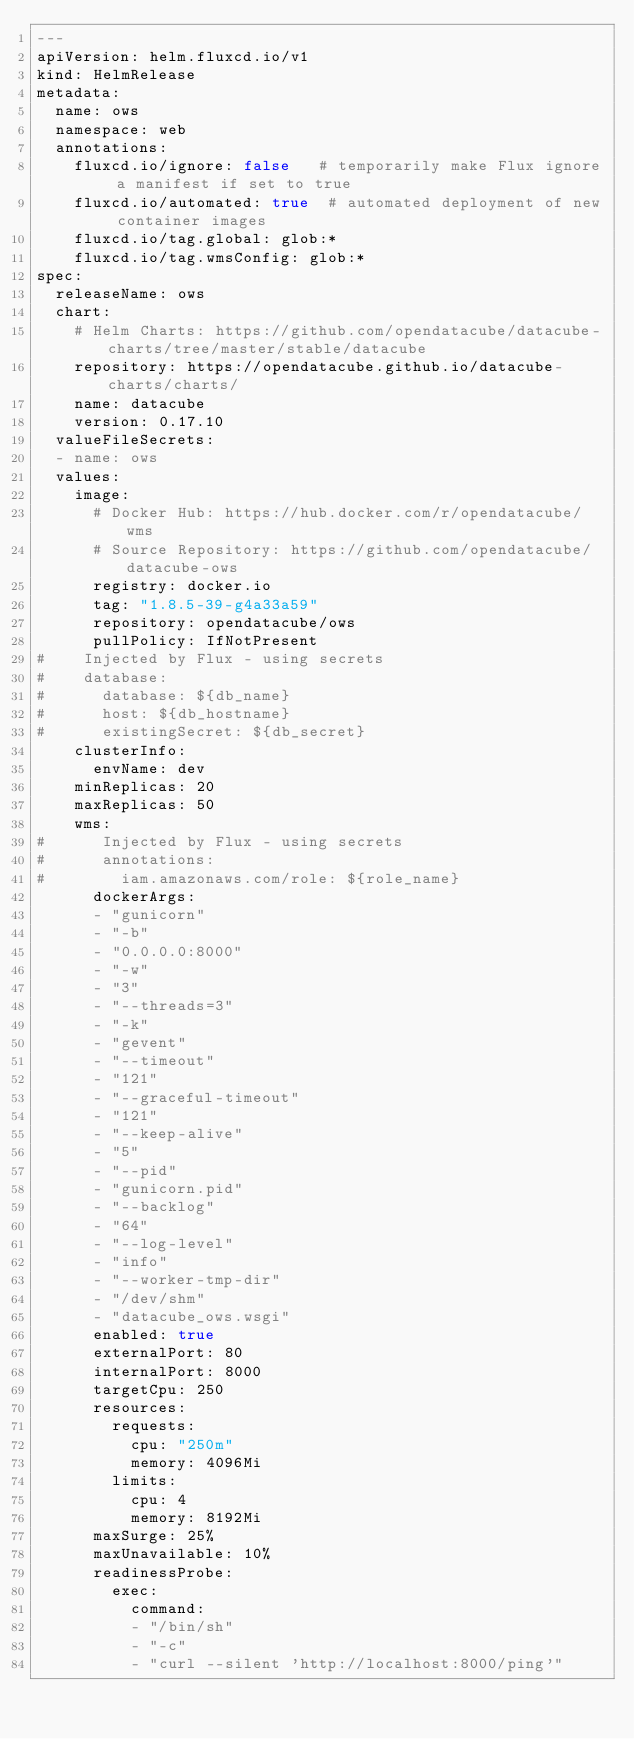Convert code to text. <code><loc_0><loc_0><loc_500><loc_500><_YAML_>---
apiVersion: helm.fluxcd.io/v1
kind: HelmRelease
metadata:
  name: ows
  namespace: web
  annotations:
    fluxcd.io/ignore: false   # temporarily make Flux ignore a manifest if set to true
    fluxcd.io/automated: true  # automated deployment of new container images
    fluxcd.io/tag.global: glob:*
    fluxcd.io/tag.wmsConfig: glob:*
spec:
  releaseName: ows
  chart:
    # Helm Charts: https://github.com/opendatacube/datacube-charts/tree/master/stable/datacube
    repository: https://opendatacube.github.io/datacube-charts/charts/
    name: datacube
    version: 0.17.10
  valueFileSecrets:
  - name: ows
  values:
    image:
      # Docker Hub: https://hub.docker.com/r/opendatacube/wms
      # Source Repository: https://github.com/opendatacube/datacube-ows
      registry: docker.io
      tag: "1.8.5-39-g4a33a59"
      repository: opendatacube/ows
      pullPolicy: IfNotPresent
#    Injected by Flux - using secrets
#    database:
#      database: ${db_name}
#      host: ${db_hostname}
#      existingSecret: ${db_secret}
    clusterInfo:
      envName: dev
    minReplicas: 20
    maxReplicas: 50
    wms:
#      Injected by Flux - using secrets
#      annotations:
#        iam.amazonaws.com/role: ${role_name}
      dockerArgs:
      - "gunicorn"
      - "-b"
      - "0.0.0.0:8000"
      - "-w"
      - "3"
      - "--threads=3"
      - "-k"
      - "gevent"
      - "--timeout"
      - "121"
      - "--graceful-timeout"
      - "121"
      - "--keep-alive"
      - "5"
      - "--pid"
      - "gunicorn.pid"
      - "--backlog"
      - "64"
      - "--log-level"
      - "info"
      - "--worker-tmp-dir"
      - "/dev/shm"
      - "datacube_ows.wsgi"
      enabled: true
      externalPort: 80
      internalPort: 8000
      targetCpu: 250
      resources:
        requests:
          cpu: "250m"
          memory: 4096Mi
        limits:
          cpu: 4
          memory: 8192Mi
      maxSurge: 25%
      maxUnavailable: 10%
      readinessProbe:
        exec:
          command:
          - "/bin/sh"
          - "-c"
          - "curl --silent 'http://localhost:8000/ping'"</code> 